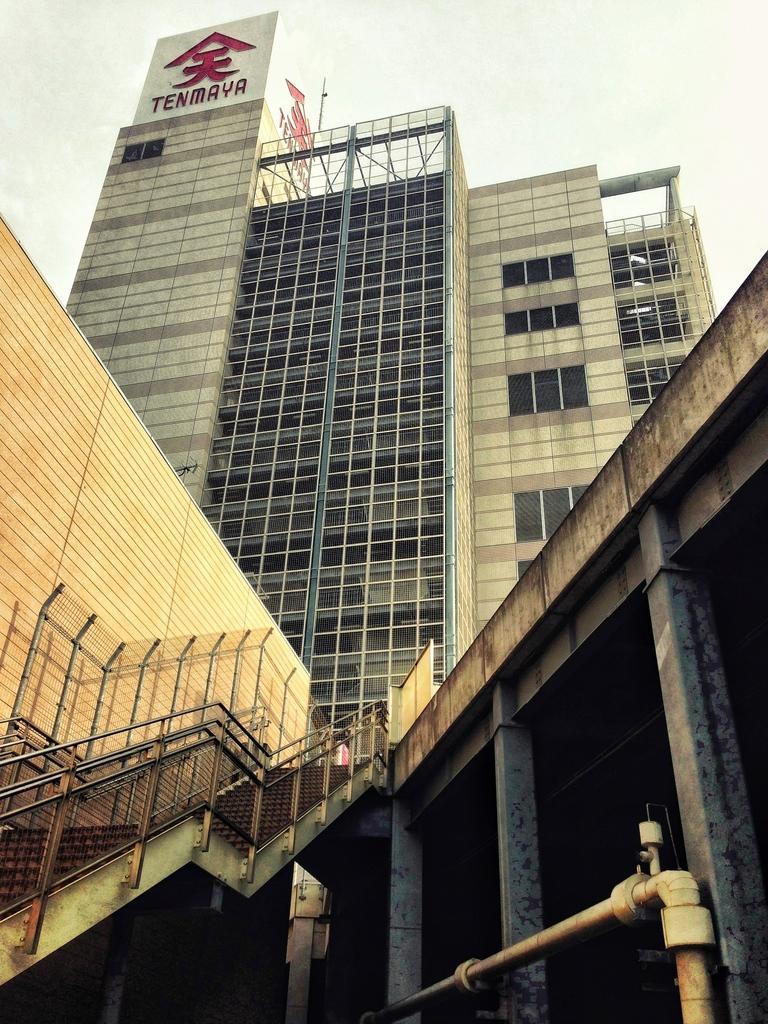How would you summarize this image in a sentence or two? In this image there is a building, in front of the building there are stairs and pillars. In the background there is the sky. 